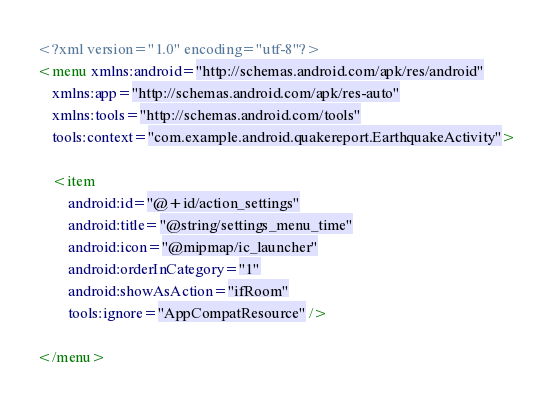<code> <loc_0><loc_0><loc_500><loc_500><_XML_><?xml version="1.0" encoding="utf-8"?>
<menu xmlns:android="http://schemas.android.com/apk/res/android"
    xmlns:app="http://schemas.android.com/apk/res-auto"
    xmlns:tools="http://schemas.android.com/tools"
    tools:context="com.example.android.quakereport.EarthquakeActivity">

    <item
        android:id="@+id/action_settings"
        android:title="@string/settings_menu_time"
        android:icon="@mipmap/ic_launcher"
        android:orderInCategory="1"
        android:showAsAction="ifRoom"
        tools:ignore="AppCompatResource" />

</menu></code> 